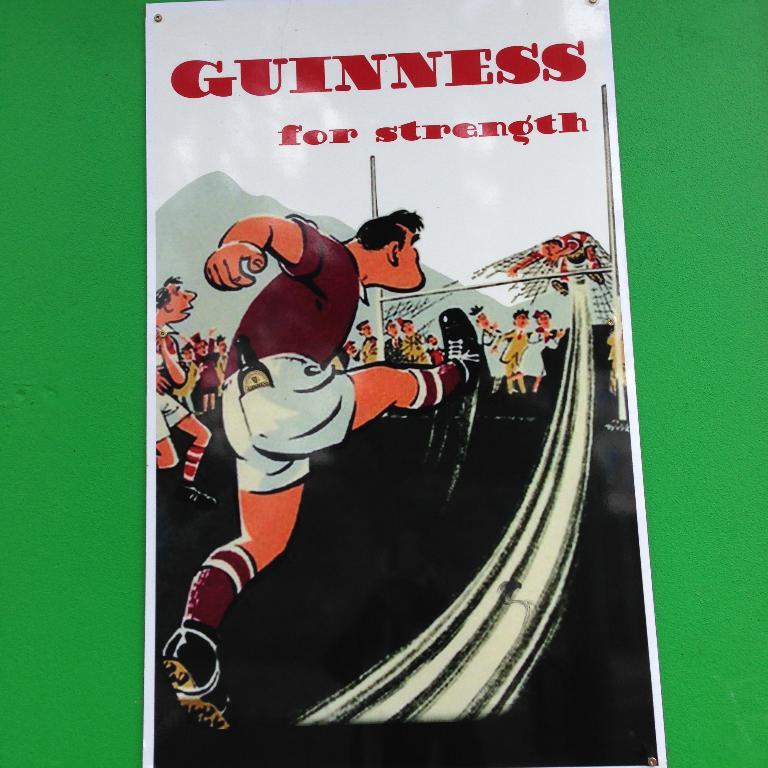What brand is advertised here?
Your answer should be very brief. Guinness. 